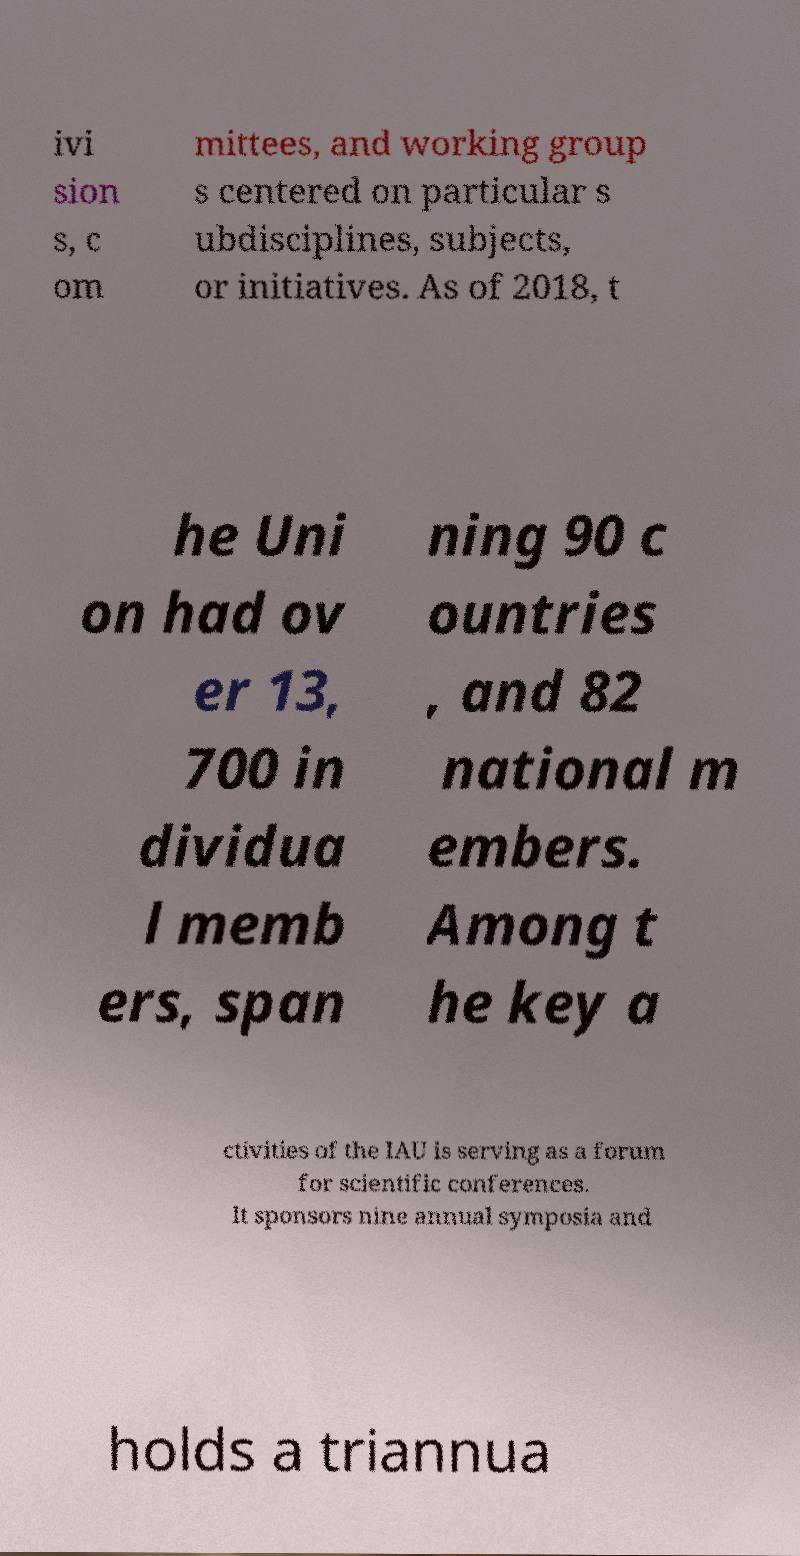Could you extract and type out the text from this image? ivi sion s, c om mittees, and working group s centered on particular s ubdisciplines, subjects, or initiatives. As of 2018, t he Uni on had ov er 13, 700 in dividua l memb ers, span ning 90 c ountries , and 82 national m embers. Among t he key a ctivities of the IAU is serving as a forum for scientific conferences. It sponsors nine annual symposia and holds a triannua 